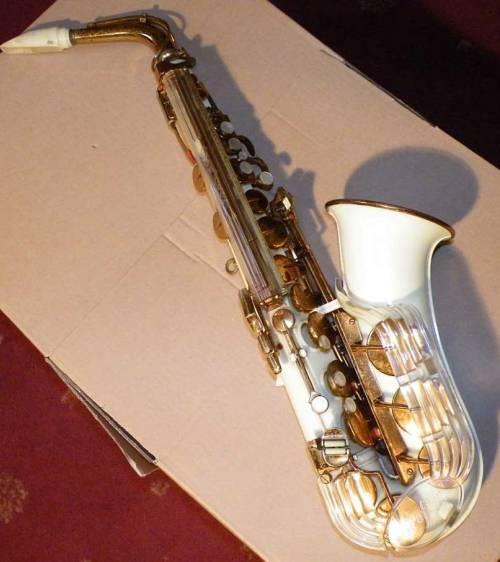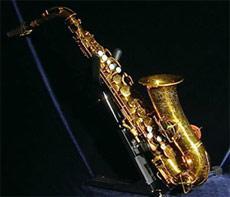The first image is the image on the left, the second image is the image on the right. Analyze the images presented: Is the assertion "At least one of the images contains a silver toned saxophone." valid? Answer yes or no. No. The first image is the image on the left, the second image is the image on the right. For the images shown, is this caption "The instruments in the left and right images share the same directional position and angle." true? Answer yes or no. Yes. 